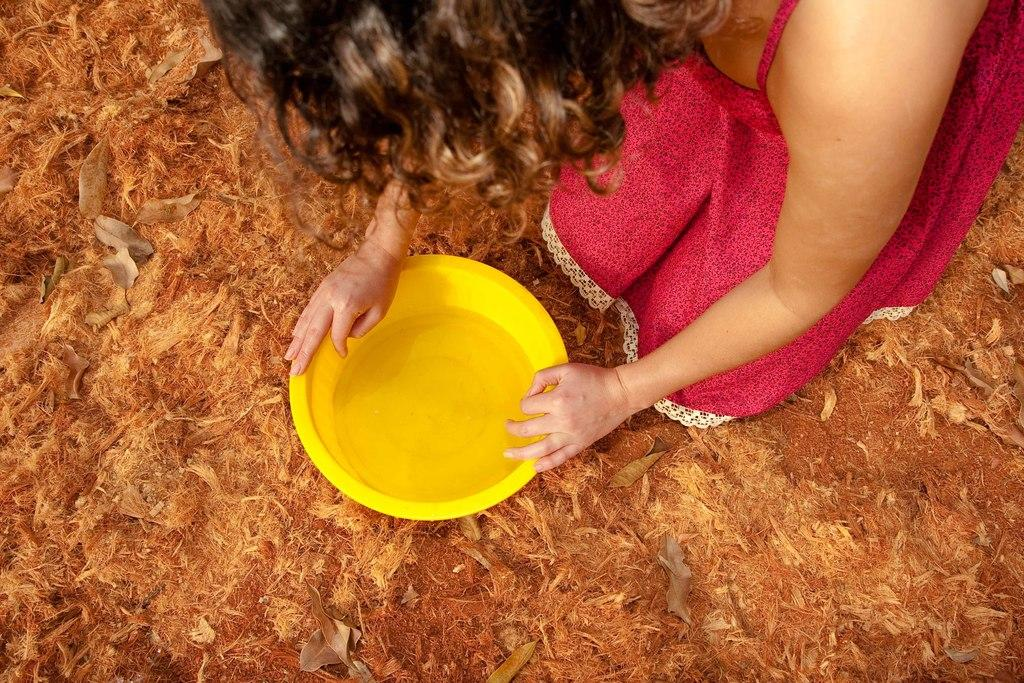Who or what is present in the image? There is a person in the image. What is the person holding in the image? The person is holding a yellow container. How is the container being held by the person? The container is held with the person's hands. What type of natural elements can be seen in the image? There are dried leaves in the image. Can you describe the surface in the image? The surface in the image is messy and brown. What type of song can be heard in the background of the image? There is no song or audio present in the image, as it is a still photograph. 